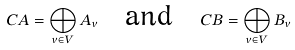<formula> <loc_0><loc_0><loc_500><loc_500>C A = \bigoplus _ { v \in V } A _ { v } \quad \text {and} \quad C B = \bigoplus _ { v \in V } B _ { v }</formula> 